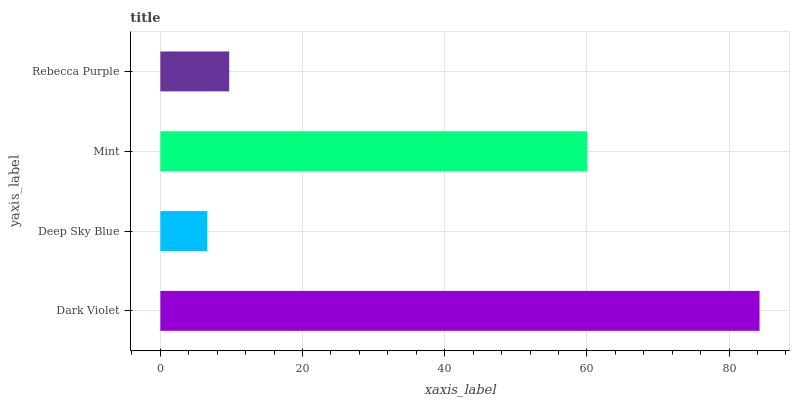Is Deep Sky Blue the minimum?
Answer yes or no. Yes. Is Dark Violet the maximum?
Answer yes or no. Yes. Is Mint the minimum?
Answer yes or no. No. Is Mint the maximum?
Answer yes or no. No. Is Mint greater than Deep Sky Blue?
Answer yes or no. Yes. Is Deep Sky Blue less than Mint?
Answer yes or no. Yes. Is Deep Sky Blue greater than Mint?
Answer yes or no. No. Is Mint less than Deep Sky Blue?
Answer yes or no. No. Is Mint the high median?
Answer yes or no. Yes. Is Rebecca Purple the low median?
Answer yes or no. Yes. Is Deep Sky Blue the high median?
Answer yes or no. No. Is Deep Sky Blue the low median?
Answer yes or no. No. 